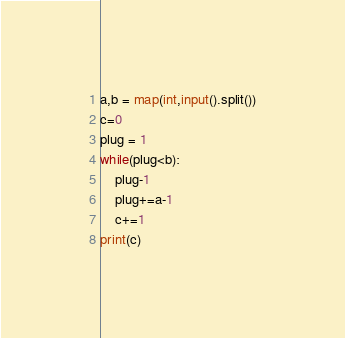Convert code to text. <code><loc_0><loc_0><loc_500><loc_500><_Python_>a,b = map(int,input().split())
c=0
plug = 1
while(plug<b):
    plug-1
    plug+=a-1
    c+=1
print(c)</code> 